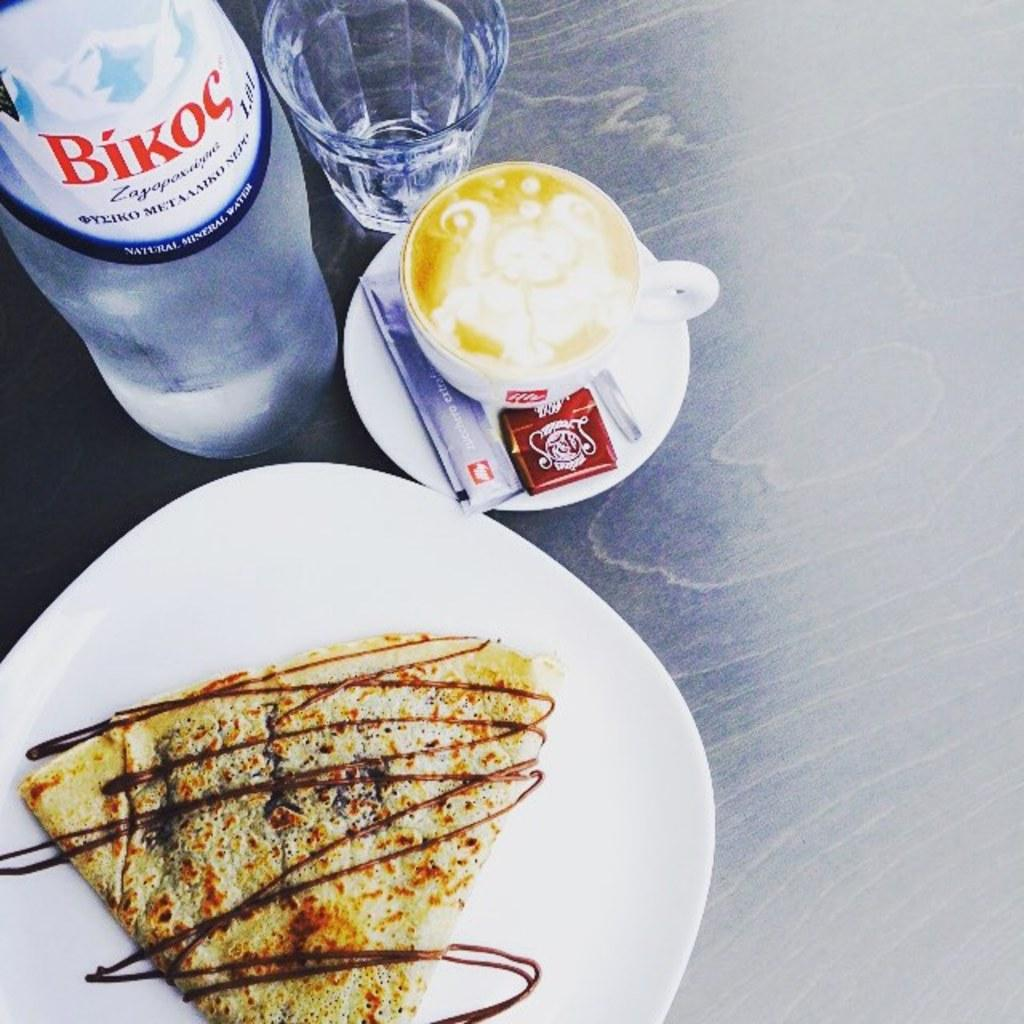<image>
Summarize the visual content of the image. a bottle of bikoc water next to a cup of coffee and a pastry of some kind 